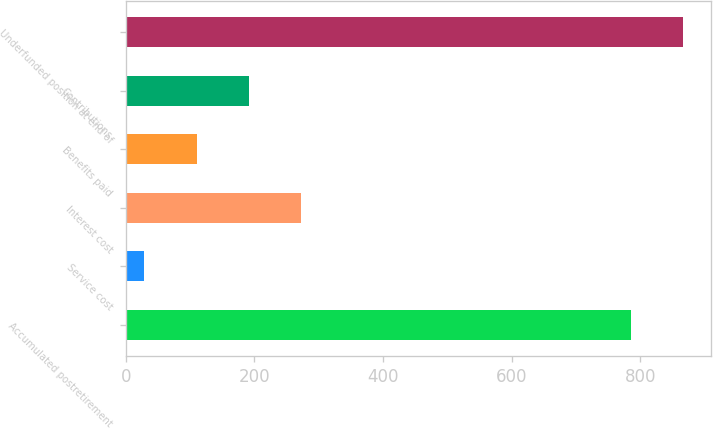Convert chart to OTSL. <chart><loc_0><loc_0><loc_500><loc_500><bar_chart><fcel>Accumulated postretirement<fcel>Service cost<fcel>Interest cost<fcel>Benefits paid<fcel>Contributions<fcel>Underfunded position at end of<nl><fcel>785<fcel>29<fcel>272.3<fcel>110.1<fcel>191.2<fcel>866.1<nl></chart> 